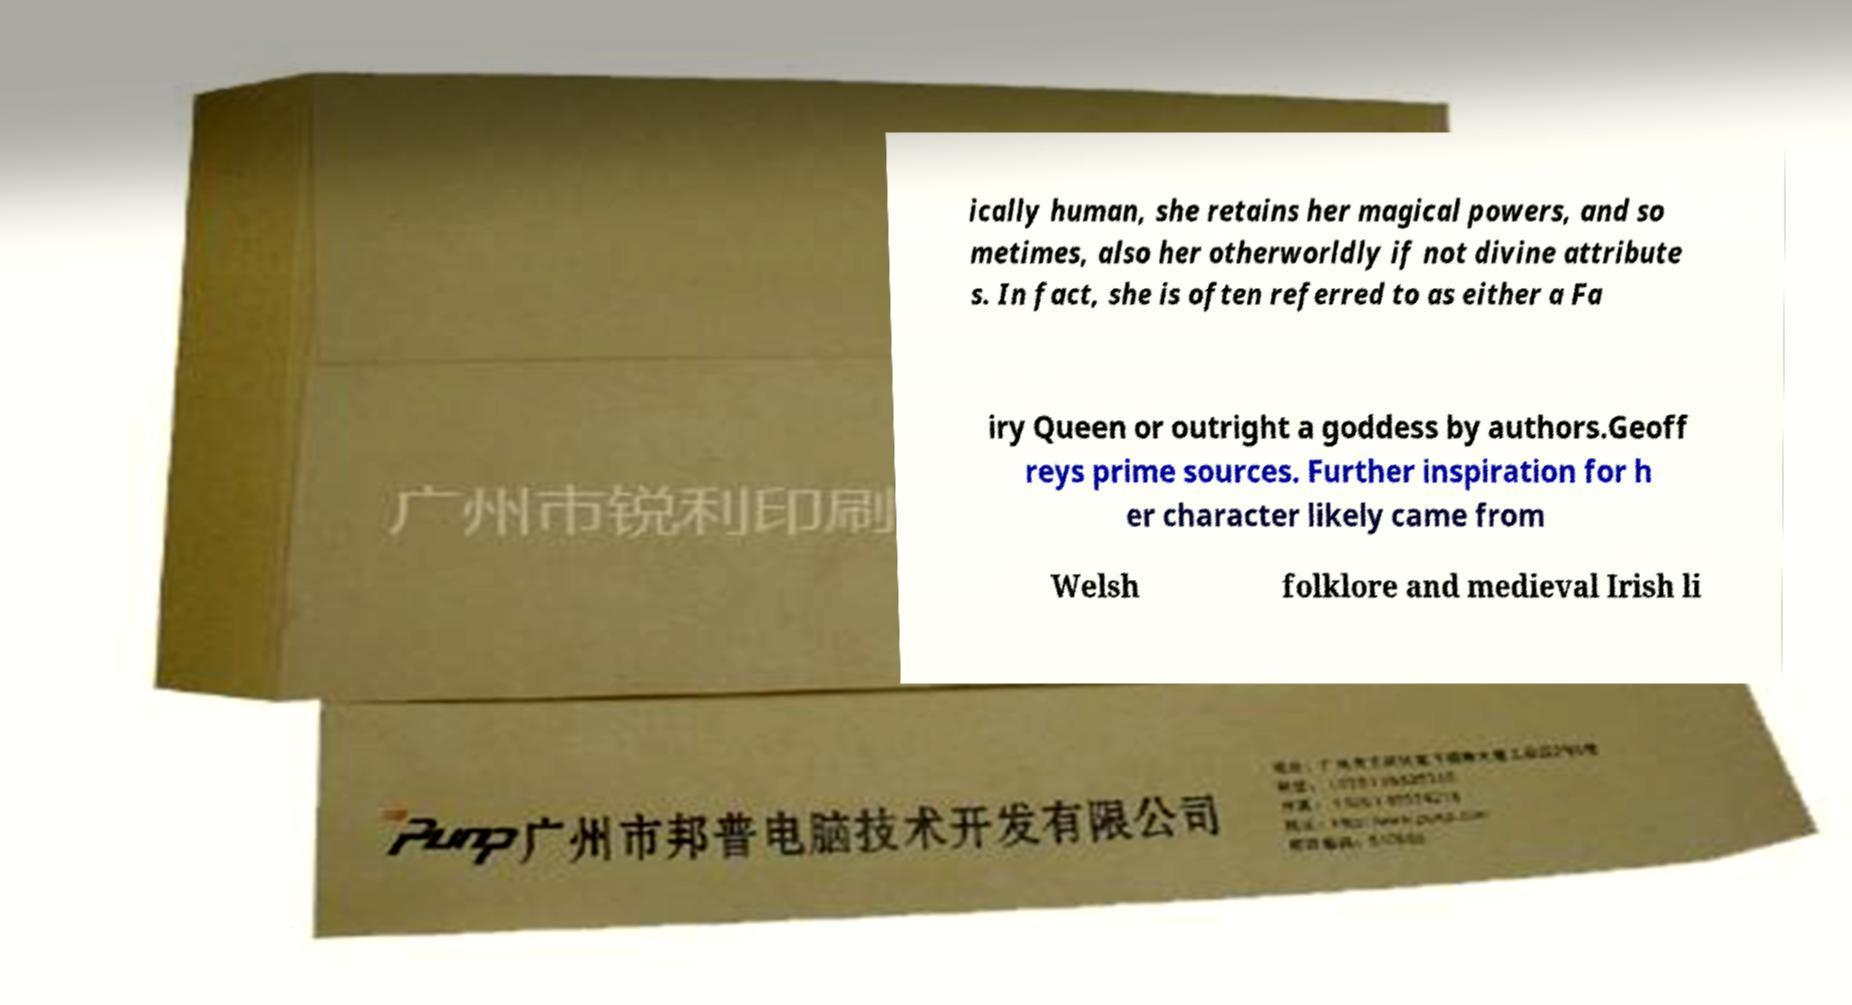Could you extract and type out the text from this image? ically human, she retains her magical powers, and so metimes, also her otherworldly if not divine attribute s. In fact, she is often referred to as either a Fa iry Queen or outright a goddess by authors.Geoff reys prime sources. Further inspiration for h er character likely came from Welsh folklore and medieval Irish li 